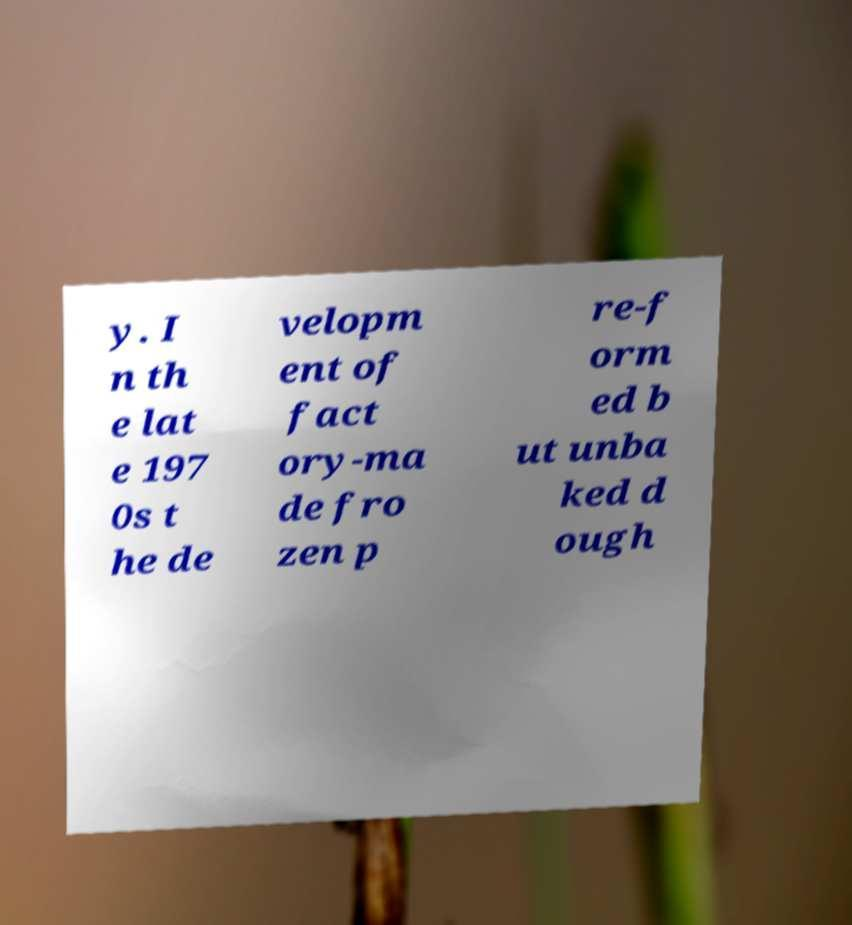There's text embedded in this image that I need extracted. Can you transcribe it verbatim? y. I n th e lat e 197 0s t he de velopm ent of fact ory-ma de fro zen p re-f orm ed b ut unba ked d ough 